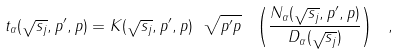<formula> <loc_0><loc_0><loc_500><loc_500>t _ { \alpha } ( \sqrt { s _ { j } } , p ^ { \prime } , p ) = K ( \sqrt { s _ { j } } , p ^ { \prime } , p ) \ \sqrt { p ^ { \prime } p } \ \left ( \frac { N _ { \alpha } ( \sqrt { s _ { j } } , p ^ { \prime } , p ) } { D _ { \alpha } ( \sqrt { s _ { j } } ) } \right ) \ ,</formula> 